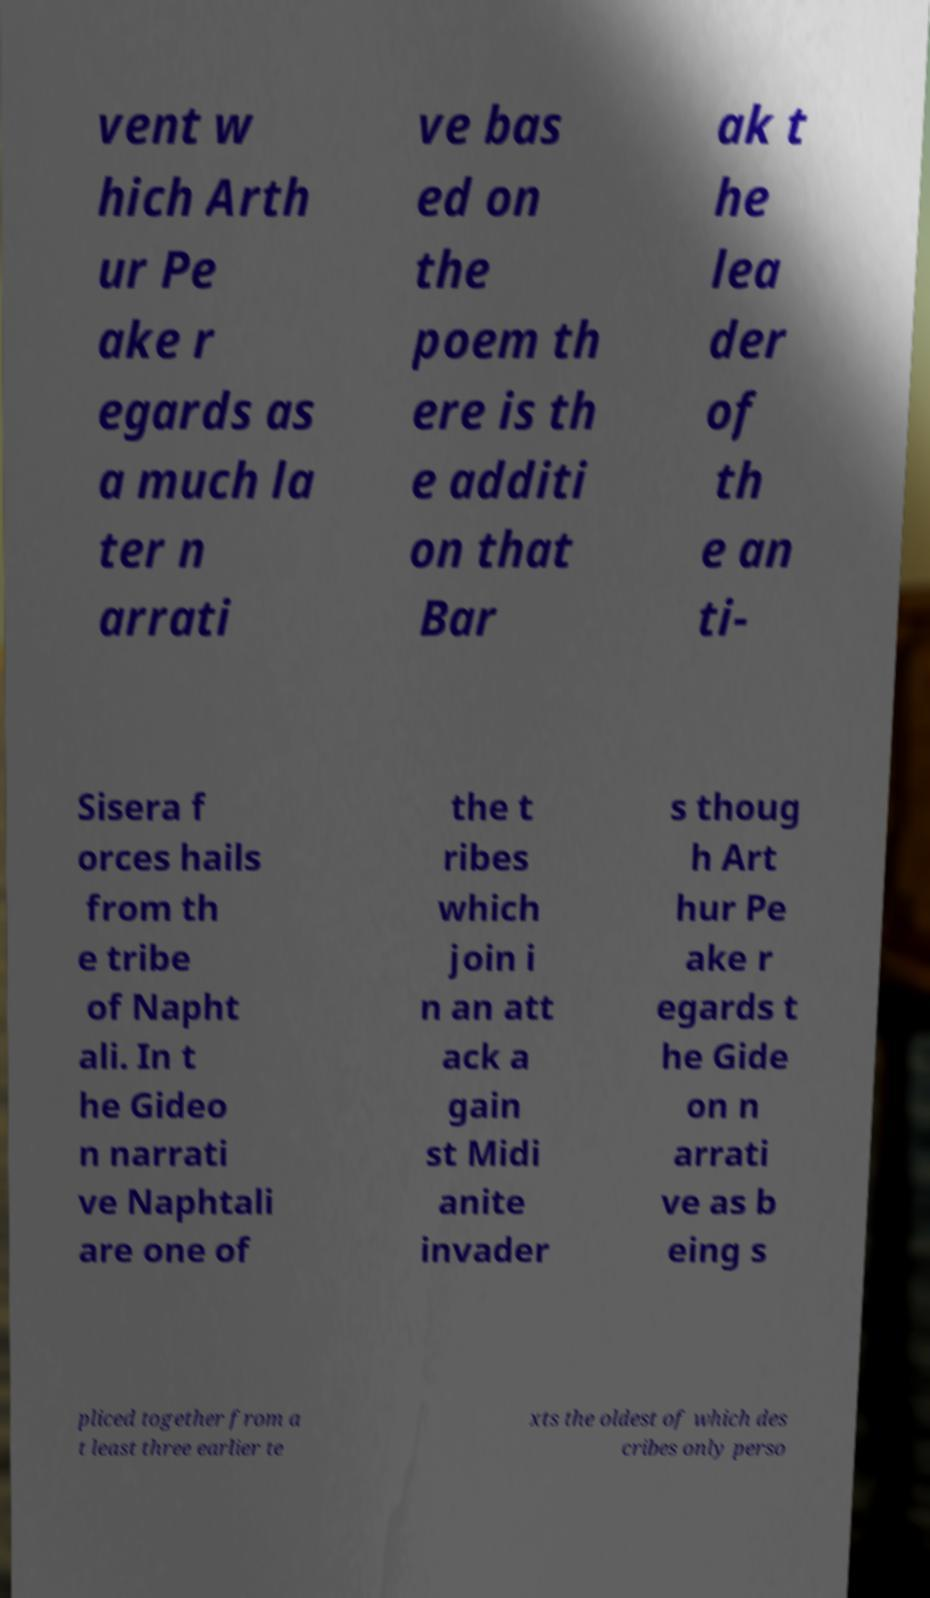Could you extract and type out the text from this image? vent w hich Arth ur Pe ake r egards as a much la ter n arrati ve bas ed on the poem th ere is th e additi on that Bar ak t he lea der of th e an ti- Sisera f orces hails from th e tribe of Napht ali. In t he Gideo n narrati ve Naphtali are one of the t ribes which join i n an att ack a gain st Midi anite invader s thoug h Art hur Pe ake r egards t he Gide on n arrati ve as b eing s pliced together from a t least three earlier te xts the oldest of which des cribes only perso 